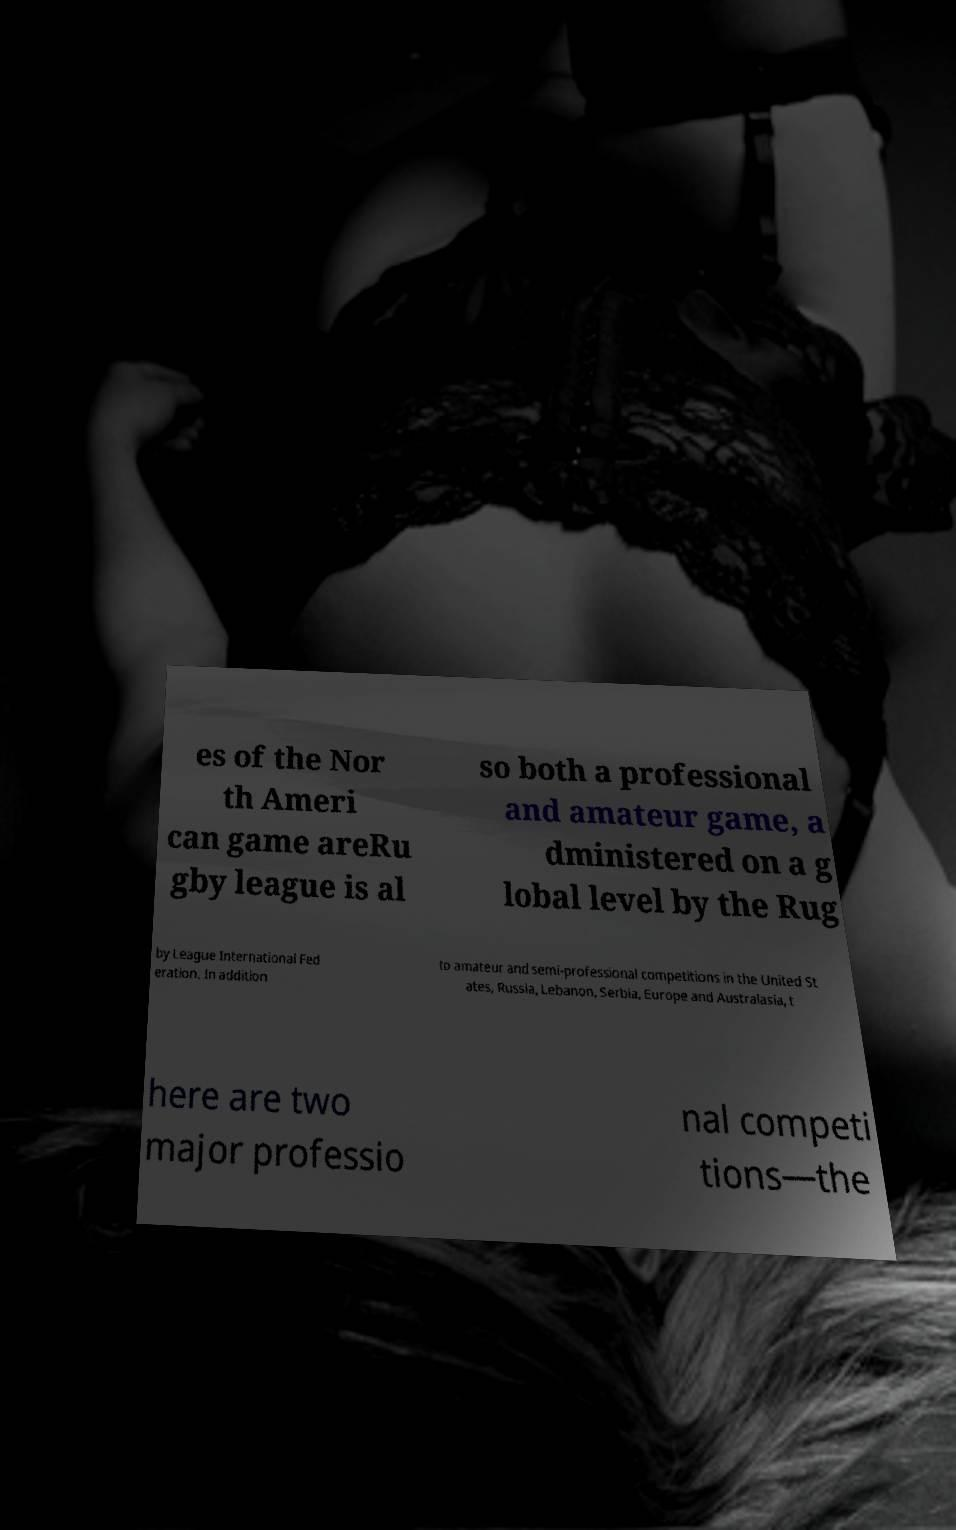Please read and relay the text visible in this image. What does it say? es of the Nor th Ameri can game areRu gby league is al so both a professional and amateur game, a dministered on a g lobal level by the Rug by League International Fed eration. In addition to amateur and semi-professional competitions in the United St ates, Russia, Lebanon, Serbia, Europe and Australasia, t here are two major professio nal competi tions—the 